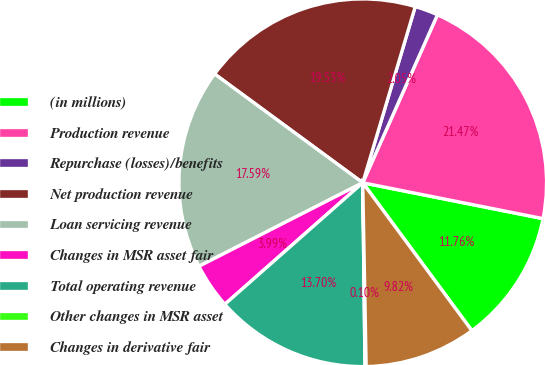<chart> <loc_0><loc_0><loc_500><loc_500><pie_chart><fcel>(in millions)<fcel>Production revenue<fcel>Repurchase (losses)/benefits<fcel>Net production revenue<fcel>Loan servicing revenue<fcel>Changes in MSR asset fair<fcel>Total operating revenue<fcel>Other changes in MSR asset<fcel>Changes in derivative fair<nl><fcel>11.76%<fcel>21.47%<fcel>2.05%<fcel>19.53%<fcel>17.59%<fcel>3.99%<fcel>13.7%<fcel>0.1%<fcel>9.82%<nl></chart> 